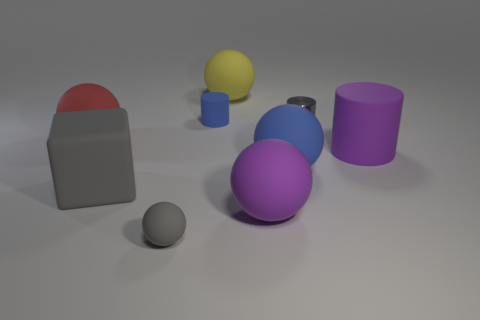Subtract all blue balls. How many balls are left? 4 Subtract all red balls. How many balls are left? 4 Subtract all cyan spheres. Subtract all cyan cylinders. How many spheres are left? 5 Add 1 gray cylinders. How many objects exist? 10 Subtract all balls. How many objects are left? 4 Add 8 gray cylinders. How many gray cylinders are left? 9 Add 9 gray cylinders. How many gray cylinders exist? 10 Subtract 0 yellow blocks. How many objects are left? 9 Subtract all tiny metallic cylinders. Subtract all large rubber blocks. How many objects are left? 7 